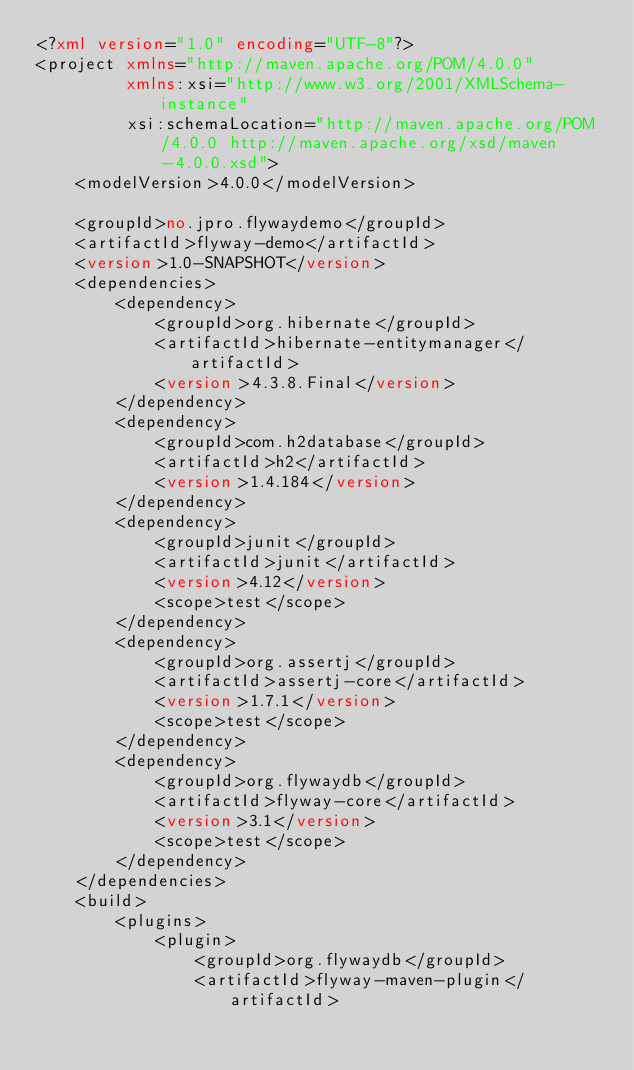Convert code to text. <code><loc_0><loc_0><loc_500><loc_500><_XML_><?xml version="1.0" encoding="UTF-8"?>
<project xmlns="http://maven.apache.org/POM/4.0.0"
         xmlns:xsi="http://www.w3.org/2001/XMLSchema-instance"
         xsi:schemaLocation="http://maven.apache.org/POM/4.0.0 http://maven.apache.org/xsd/maven-4.0.0.xsd">
    <modelVersion>4.0.0</modelVersion>

    <groupId>no.jpro.flywaydemo</groupId>
    <artifactId>flyway-demo</artifactId>
    <version>1.0-SNAPSHOT</version>
    <dependencies>
        <dependency>
            <groupId>org.hibernate</groupId>
            <artifactId>hibernate-entitymanager</artifactId>
            <version>4.3.8.Final</version>
        </dependency>
        <dependency>
            <groupId>com.h2database</groupId>
            <artifactId>h2</artifactId>
            <version>1.4.184</version>
        </dependency>
        <dependency>
            <groupId>junit</groupId>
            <artifactId>junit</artifactId>
            <version>4.12</version>
            <scope>test</scope>
        </dependency>
        <dependency>
            <groupId>org.assertj</groupId>
            <artifactId>assertj-core</artifactId>
            <version>1.7.1</version>
            <scope>test</scope>
        </dependency>
        <dependency>
            <groupId>org.flywaydb</groupId>
            <artifactId>flyway-core</artifactId>
            <version>3.1</version>
            <scope>test</scope>
        </dependency>
    </dependencies>
    <build>
        <plugins>
            <plugin>
                <groupId>org.flywaydb</groupId>
                <artifactId>flyway-maven-plugin</artifactId></code> 